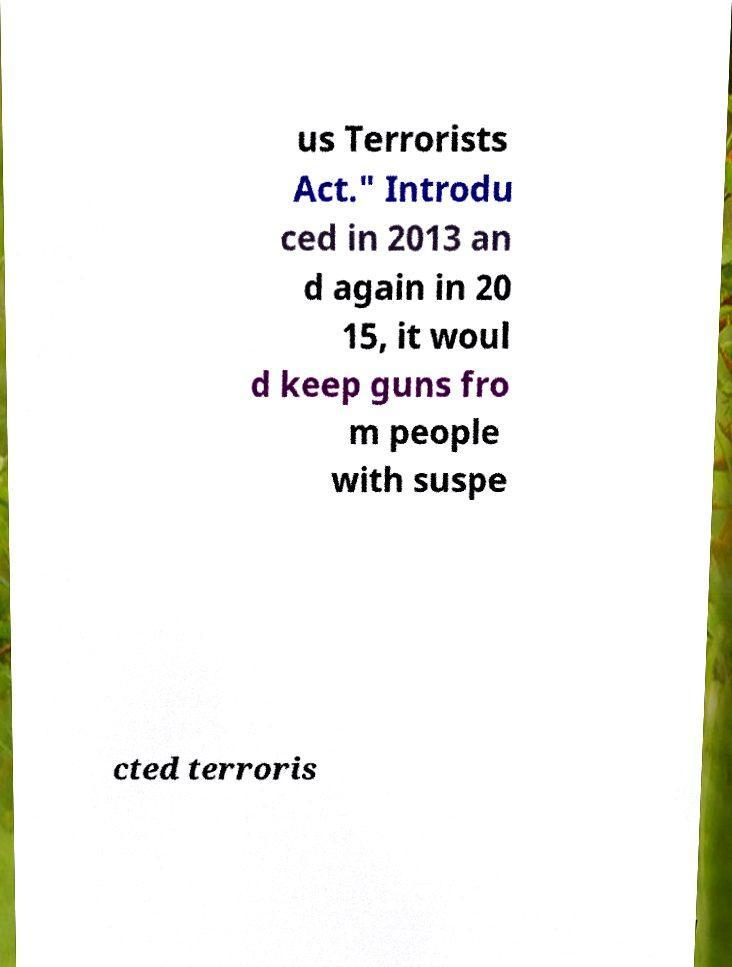Could you extract and type out the text from this image? us Terrorists Act." Introdu ced in 2013 an d again in 20 15, it woul d keep guns fro m people with suspe cted terroris 